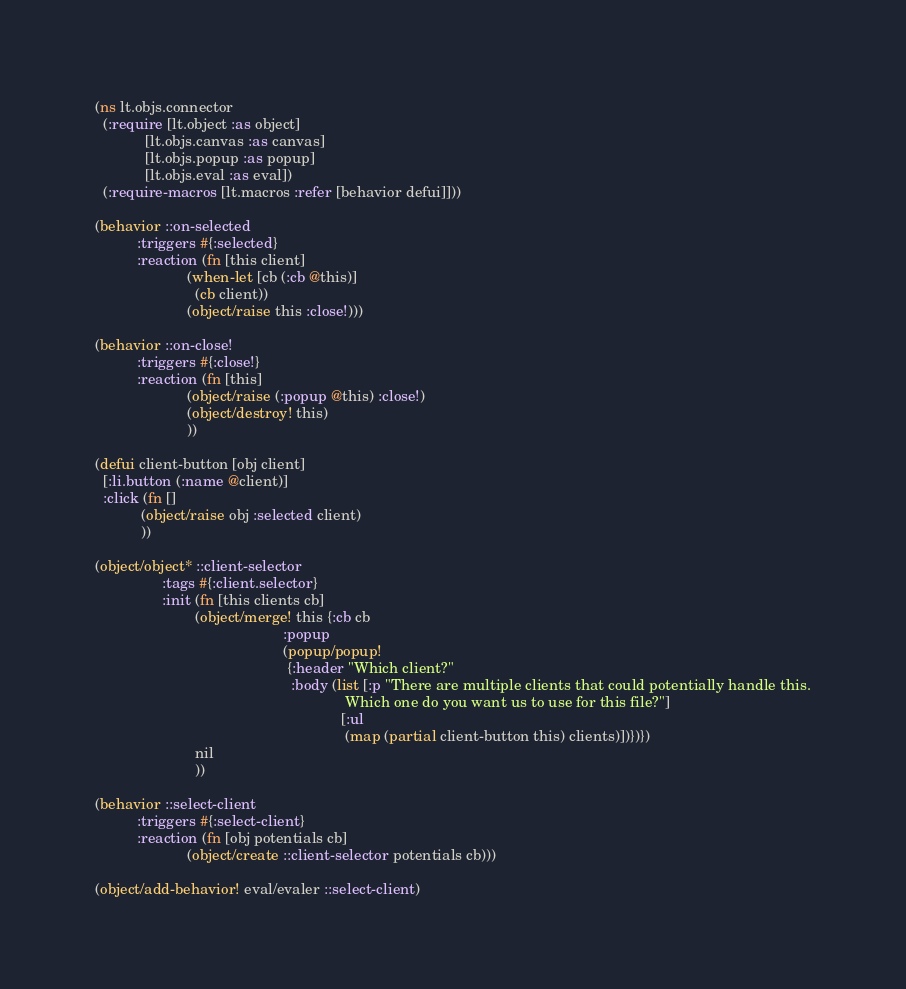<code> <loc_0><loc_0><loc_500><loc_500><_Clojure_>(ns lt.objs.connector
  (:require [lt.object :as object]
            [lt.objs.canvas :as canvas]
            [lt.objs.popup :as popup]
            [lt.objs.eval :as eval])
  (:require-macros [lt.macros :refer [behavior defui]]))

(behavior ::on-selected
          :triggers #{:selected}
          :reaction (fn [this client]
                      (when-let [cb (:cb @this)]
                        (cb client))
                      (object/raise this :close!)))

(behavior ::on-close!
          :triggers #{:close!}
          :reaction (fn [this]
                      (object/raise (:popup @this) :close!)
                      (object/destroy! this)
                      ))

(defui client-button [obj client]
  [:li.button (:name @client)]
  :click (fn []
           (object/raise obj :selected client)
           ))

(object/object* ::client-selector
                :tags #{:client.selector}
                :init (fn [this clients cb]
                        (object/merge! this {:cb cb
                                             :popup
                                             (popup/popup!
                                              {:header "Which client?"
                                               :body (list [:p "There are multiple clients that could potentially handle this.
                                                            Which one do you want us to use for this file?"]
                                                           [:ul
                                                            (map (partial client-button this) clients)])})})
                        nil
                        ))

(behavior ::select-client
          :triggers #{:select-client}
          :reaction (fn [obj potentials cb]
                      (object/create ::client-selector potentials cb)))

(object/add-behavior! eval/evaler ::select-client)
</code> 